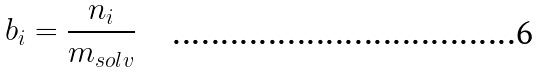Convert formula to latex. <formula><loc_0><loc_0><loc_500><loc_500>b _ { i } = \frac { n _ { i } } { m _ { s o l v } }</formula> 